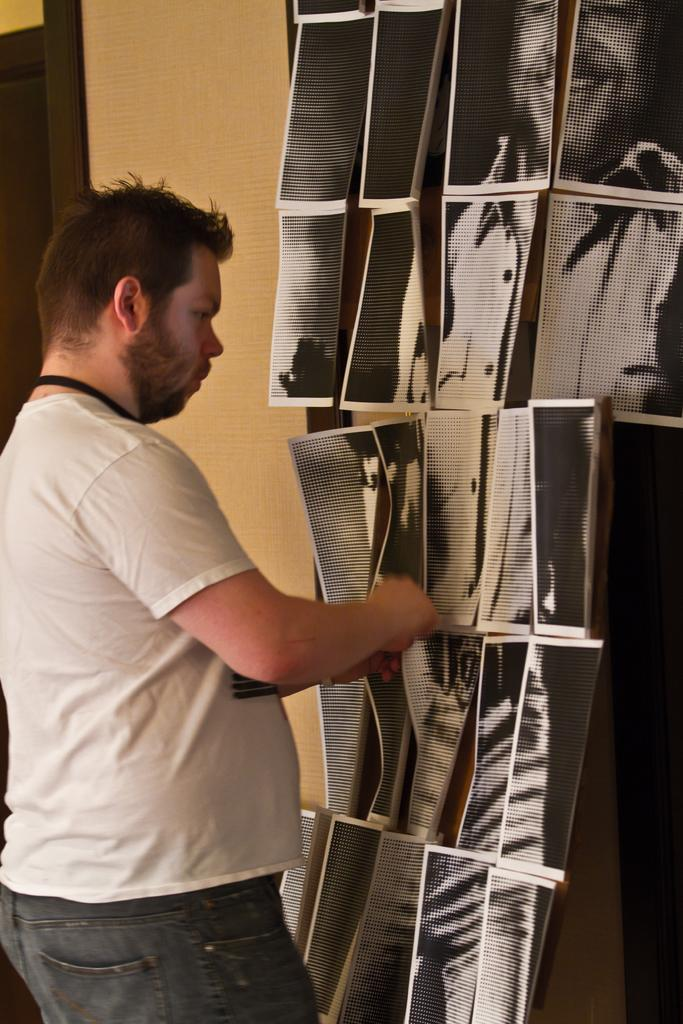What is the main subject in the foreground of the image? There is a man standing in the foreground of the image on the left side. What can be seen on the right side of the image? There are posters on a board on the right side of the image. What is visible in the background of the image? There is a wall visible in the background of the image. What type of cream can be seen on the wall in the image? There is no cream visible on the wall in the image. How does the pollution affect the scene in the image? There is no mention of pollution in the image, so it cannot be determined how it affects the scene. 